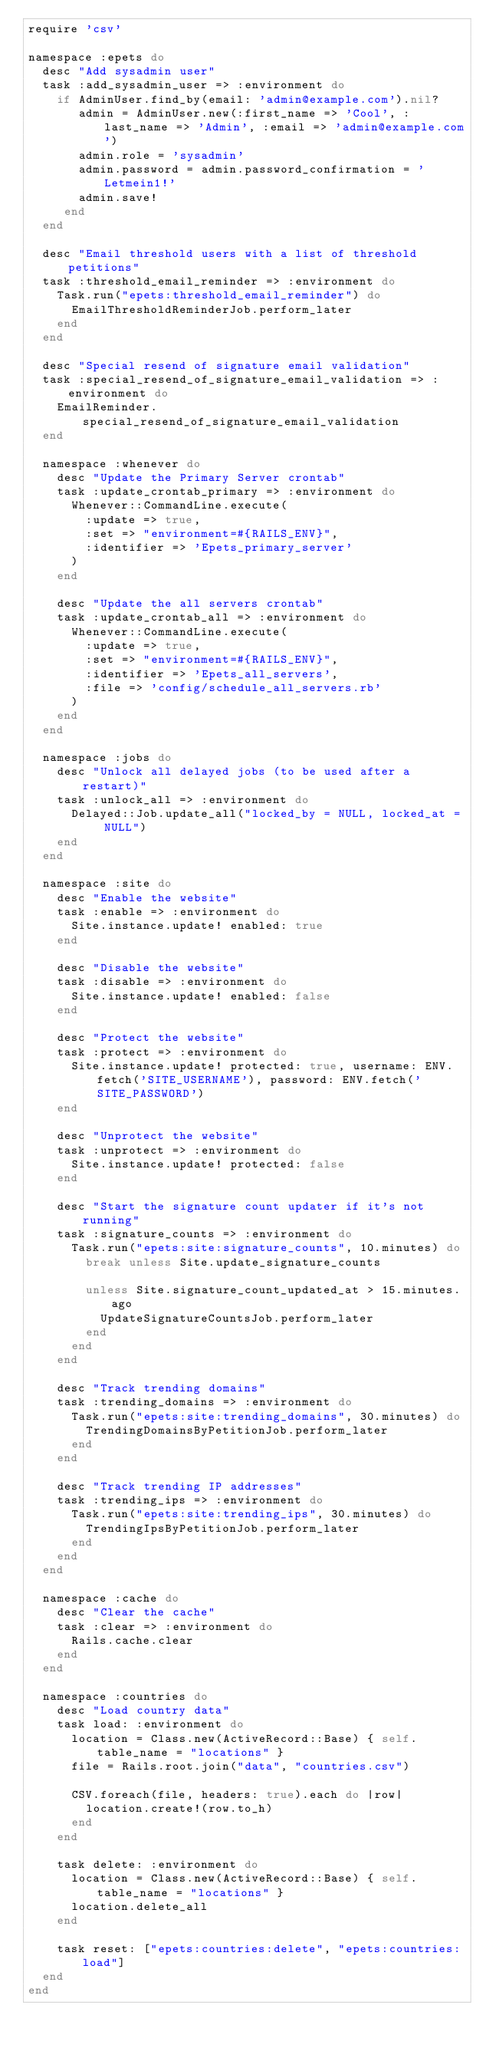<code> <loc_0><loc_0><loc_500><loc_500><_Ruby_>require 'csv'

namespace :epets do
  desc "Add sysadmin user"
  task :add_sysadmin_user => :environment do
    if AdminUser.find_by(email: 'admin@example.com').nil?
       admin = AdminUser.new(:first_name => 'Cool', :last_name => 'Admin', :email => 'admin@example.com')
       admin.role = 'sysadmin'
       admin.password = admin.password_confirmation = 'Letmein1!'
       admin.save!
     end
  end

  desc "Email threshold users with a list of threshold petitions"
  task :threshold_email_reminder => :environment do
    Task.run("epets:threshold_email_reminder") do
      EmailThresholdReminderJob.perform_later
    end
  end

  desc "Special resend of signature email validation"
  task :special_resend_of_signature_email_validation => :environment do
    EmailReminder.special_resend_of_signature_email_validation
  end

  namespace :whenever do
    desc "Update the Primary Server crontab"
    task :update_crontab_primary => :environment do
      Whenever::CommandLine.execute(
        :update => true,
        :set => "environment=#{RAILS_ENV}",
        :identifier => 'Epets_primary_server'
      )
    end

    desc "Update the all servers crontab"
    task :update_crontab_all => :environment do
      Whenever::CommandLine.execute(
        :update => true,
        :set => "environment=#{RAILS_ENV}",
        :identifier => 'Epets_all_servers',
        :file => 'config/schedule_all_servers.rb'
      )
    end
  end

  namespace :jobs do
    desc "Unlock all delayed jobs (to be used after a restart)"
    task :unlock_all => :environment do
      Delayed::Job.update_all("locked_by = NULL, locked_at = NULL")
    end
  end

  namespace :site do
    desc "Enable the website"
    task :enable => :environment do
      Site.instance.update! enabled: true
    end

    desc "Disable the website"
    task :disable => :environment do
      Site.instance.update! enabled: false
    end

    desc "Protect the website"
    task :protect => :environment do
      Site.instance.update! protected: true, username: ENV.fetch('SITE_USERNAME'), password: ENV.fetch('SITE_PASSWORD')
    end

    desc "Unprotect the website"
    task :unprotect => :environment do
      Site.instance.update! protected: false
    end

    desc "Start the signature count updater if it's not running"
    task :signature_counts => :environment do
      Task.run("epets:site:signature_counts", 10.minutes) do
        break unless Site.update_signature_counts

        unless Site.signature_count_updated_at > 15.minutes.ago
          UpdateSignatureCountsJob.perform_later
        end
      end
    end

    desc "Track trending domains"
    task :trending_domains => :environment do
      Task.run("epets:site:trending_domains", 30.minutes) do
        TrendingDomainsByPetitionJob.perform_later
      end
    end

    desc "Track trending IP addresses"
    task :trending_ips => :environment do
      Task.run("epets:site:trending_ips", 30.minutes) do
        TrendingIpsByPetitionJob.perform_later
      end
    end
  end

  namespace :cache do
    desc "Clear the cache"
    task :clear => :environment do
      Rails.cache.clear
    end
  end

  namespace :countries do
    desc "Load country data"
    task load: :environment do
      location = Class.new(ActiveRecord::Base) { self.table_name = "locations" }
      file = Rails.root.join("data", "countries.csv")

      CSV.foreach(file, headers: true).each do |row|
        location.create!(row.to_h)
      end
    end

    task delete: :environment do
      location = Class.new(ActiveRecord::Base) { self.table_name = "locations" }
      location.delete_all
    end

    task reset: ["epets:countries:delete", "epets:countries:load"]
  end
end
</code> 